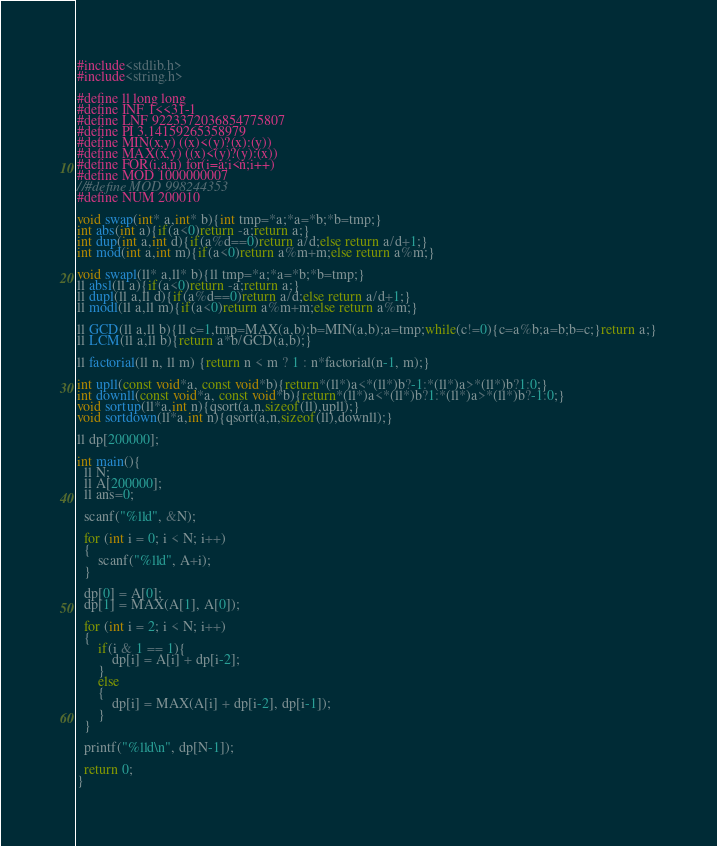Convert code to text. <code><loc_0><loc_0><loc_500><loc_500><_C_>#include<stdlib.h>
#include<string.h>

#define ll long long
#define INF 1<<31-1
#define LNF 9223372036854775807
#define PI 3.14159265358979
#define MIN(x,y) ((x)<(y)?(x):(y))
#define MAX(x,y) ((x)<(y)?(y):(x))
#define FOR(i,a,n) for(i=a;i<n;i++)
#define MOD 1000000007
//#define MOD 998244353
#define NUM 200010
 
void swap(int* a,int* b){int tmp=*a;*a=*b;*b=tmp;}
int abs(int a){if(a<0)return -a;return a;}
int dup(int a,int d){if(a%d==0)return a/d;else return a/d+1;}
int mod(int a,int m){if(a<0)return a%m+m;else return a%m;}

void swapl(ll* a,ll* b){ll tmp=*a;*a=*b;*b=tmp;}
ll absl(ll a){if(a<0)return -a;return a;}
ll dupl(ll a,ll d){if(a%d==0)return a/d;else return a/d+1;}
ll modl(ll a,ll m){if(a<0)return a%m+m;else return a%m;}

ll GCD(ll a,ll b){ll c=1,tmp=MAX(a,b);b=MIN(a,b);a=tmp;while(c!=0){c=a%b;a=b;b=c;}return a;}
ll LCM(ll a,ll b){return a*b/GCD(a,b);}

ll factorial(ll n, ll m) {return n < m ? 1 : n*factorial(n-1, m);}

int upll(const void*a, const void*b){return*(ll*)a<*(ll*)b?-1:*(ll*)a>*(ll*)b?1:0;}
int downll(const void*a, const void*b){return*(ll*)a<*(ll*)b?1:*(ll*)a>*(ll*)b?-1:0;}
void sortup(ll*a,int n){qsort(a,n,sizeof(ll),upll);}
void sortdown(ll*a,int n){qsort(a,n,sizeof(ll),downll);}

ll dp[200000];

int main(){
  ll N;
  ll A[200000];
  ll ans=0;
  
  scanf("%lld", &N);

  for (int i = 0; i < N; i++)
  {
      scanf("%lld", A+i);
  }
  
  dp[0] = A[0];
  dp[1] = MAX(A[1], A[0]);

  for (int i = 2; i < N; i++)
  {
      if(i & 1 == 1){
          dp[i] = A[i] + dp[i-2];
      }
      else
      {
          dp[i] = MAX(A[i] + dp[i-2], dp[i-1]);          
      }
  }

  printf("%lld\n", dp[N-1]);
  
  return 0;
}
</code> 